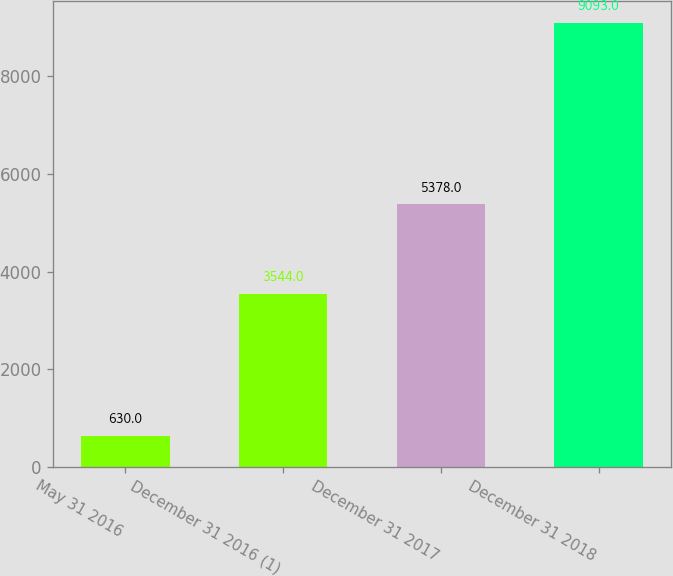Convert chart to OTSL. <chart><loc_0><loc_0><loc_500><loc_500><bar_chart><fcel>May 31 2016<fcel>December 31 2016 (1)<fcel>December 31 2017<fcel>December 31 2018<nl><fcel>630<fcel>3544<fcel>5378<fcel>9093<nl></chart> 